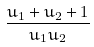Convert formula to latex. <formula><loc_0><loc_0><loc_500><loc_500>\frac { u _ { 1 } + u _ { 2 } + 1 } { u _ { 1 } u _ { 2 } }</formula> 